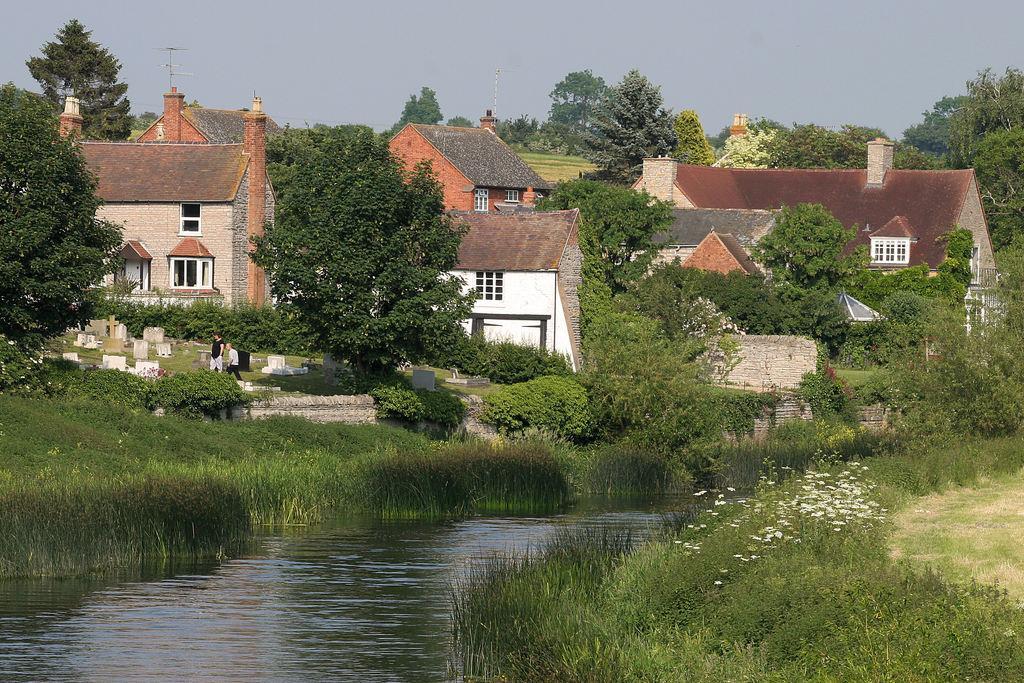In one or two sentences, can you explain what this image depicts? In this image there is water, plants with flowers, grass, buildings, graveyard, two persons standing, trees,sky. 